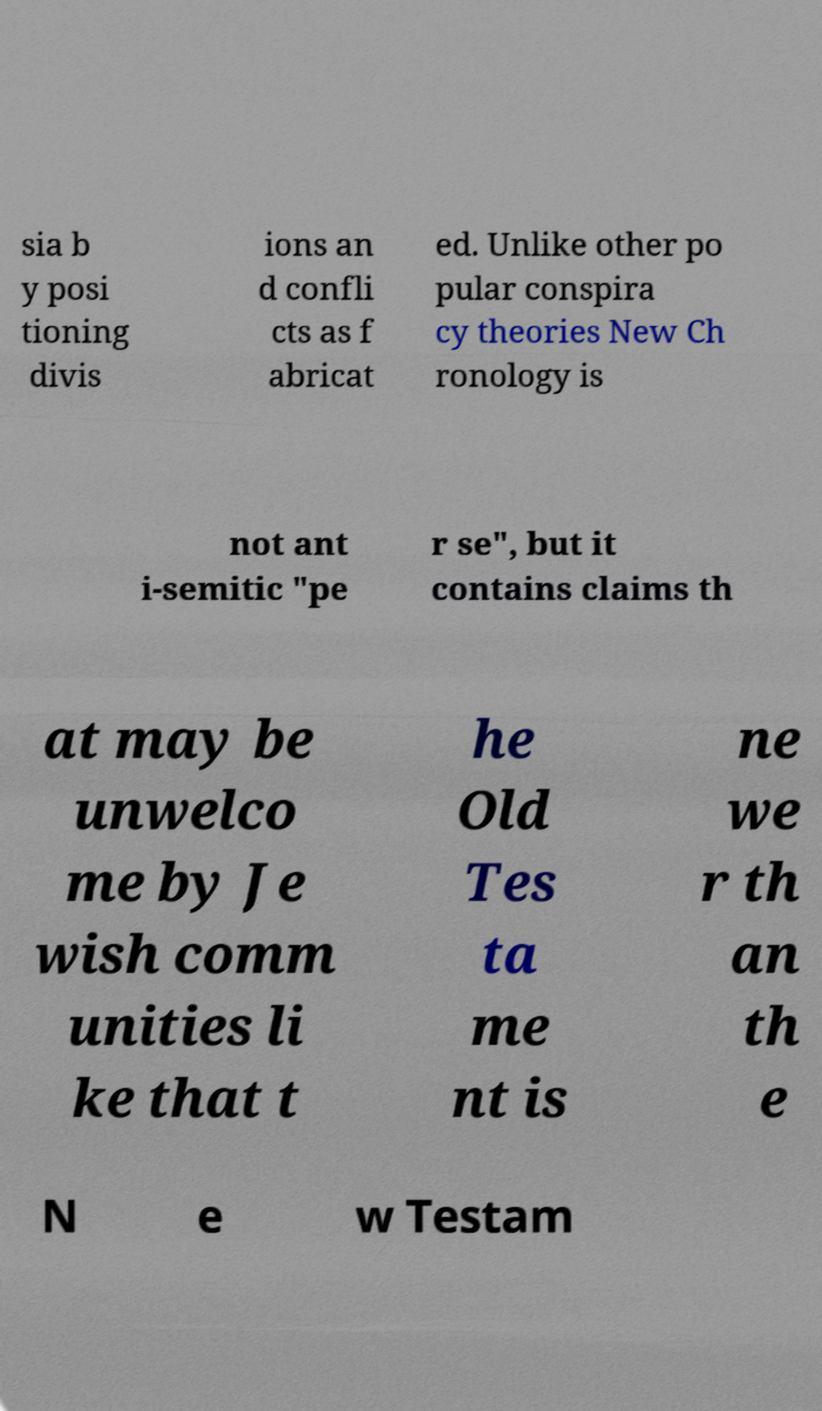Please identify and transcribe the text found in this image. sia b y posi tioning divis ions an d confli cts as f abricat ed. Unlike other po pular conspira cy theories New Ch ronology is not ant i-semitic "pe r se", but it contains claims th at may be unwelco me by Je wish comm unities li ke that t he Old Tes ta me nt is ne we r th an th e N e w Testam 